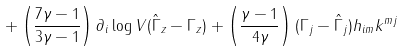Convert formula to latex. <formula><loc_0><loc_0><loc_500><loc_500>+ \left ( \frac { 7 \gamma - 1 } { 3 \gamma - 1 } \right ) \partial _ { i } \log V ( \hat { \Gamma } _ { z } - \Gamma _ { z } ) + \left ( \frac { \gamma - 1 } { 4 \gamma } \right ) ( \Gamma _ { j } - \hat { \Gamma } _ { j } ) h _ { i m } k ^ { m j }</formula> 